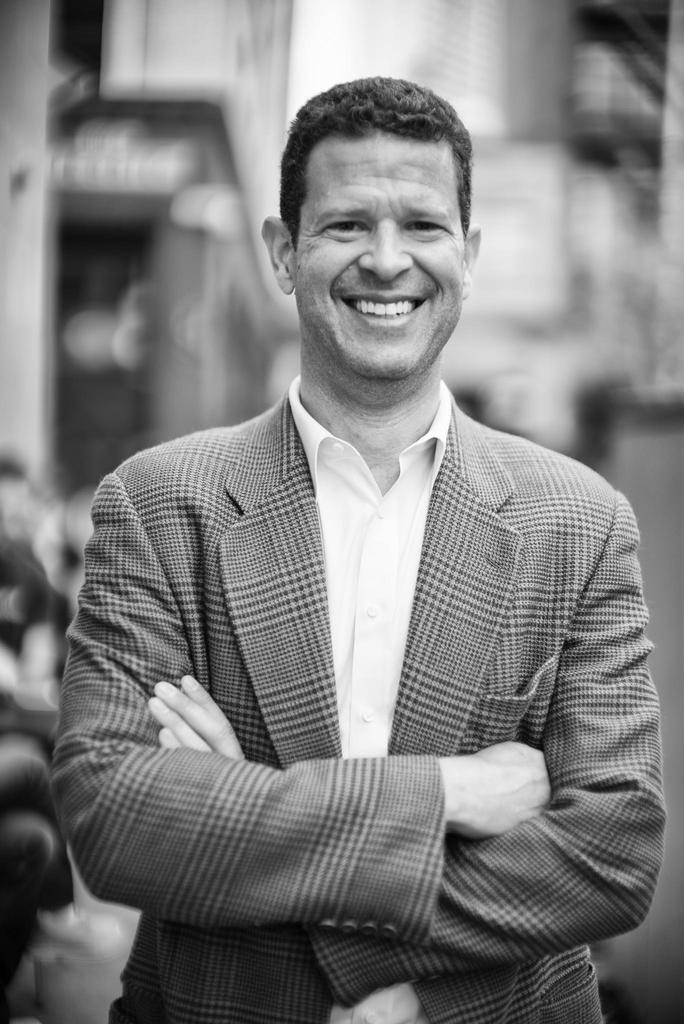Could you give a brief overview of what you see in this image? It is a black and white picture. In this image, we can see a person is watching and smiling. He folded his hands. Background we can see the blur view. 